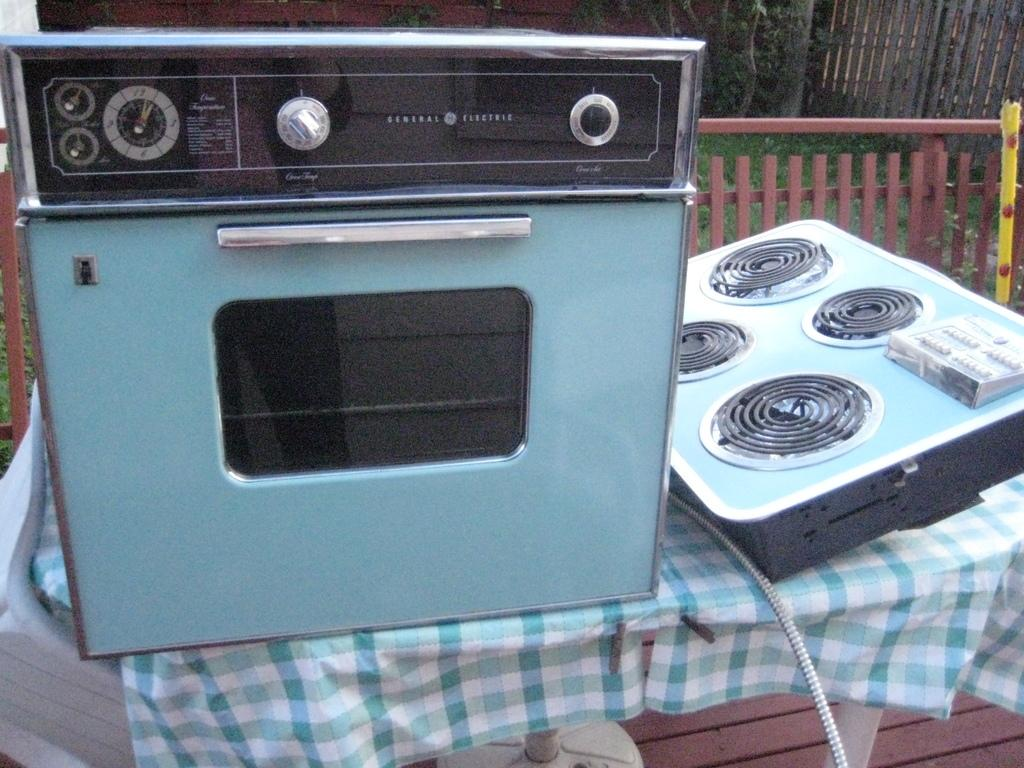<image>
Relay a brief, clear account of the picture shown. Blue and black oven that says General Electric on the top. 